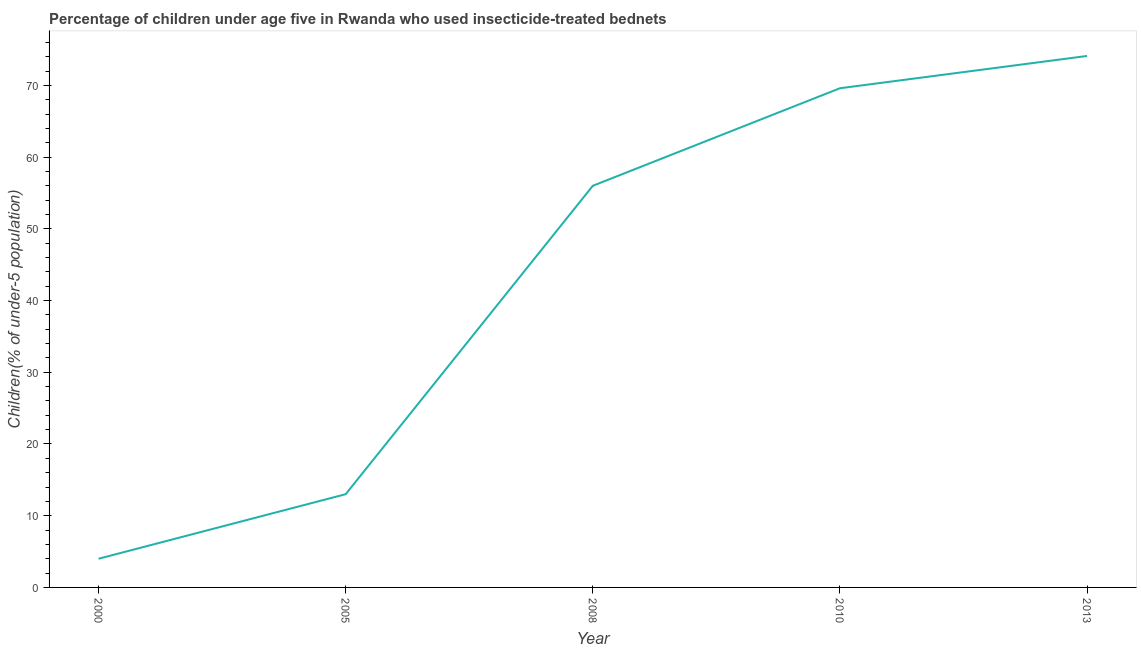What is the percentage of children who use of insecticide-treated bed nets in 2013?
Your response must be concise. 74.1. Across all years, what is the maximum percentage of children who use of insecticide-treated bed nets?
Your answer should be very brief. 74.1. What is the sum of the percentage of children who use of insecticide-treated bed nets?
Provide a succinct answer. 216.7. What is the difference between the percentage of children who use of insecticide-treated bed nets in 2008 and 2013?
Make the answer very short. -18.1. What is the average percentage of children who use of insecticide-treated bed nets per year?
Provide a short and direct response. 43.34. What is the median percentage of children who use of insecticide-treated bed nets?
Your answer should be compact. 56. In how many years, is the percentage of children who use of insecticide-treated bed nets greater than 66 %?
Offer a terse response. 2. What is the ratio of the percentage of children who use of insecticide-treated bed nets in 2005 to that in 2010?
Offer a terse response. 0.19. What is the difference between the highest and the lowest percentage of children who use of insecticide-treated bed nets?
Your answer should be compact. 70.1. Does the percentage of children who use of insecticide-treated bed nets monotonically increase over the years?
Provide a short and direct response. Yes. How many lines are there?
Give a very brief answer. 1. Are the values on the major ticks of Y-axis written in scientific E-notation?
Your response must be concise. No. Does the graph contain any zero values?
Offer a very short reply. No. Does the graph contain grids?
Keep it short and to the point. No. What is the title of the graph?
Your answer should be very brief. Percentage of children under age five in Rwanda who used insecticide-treated bednets. What is the label or title of the Y-axis?
Keep it short and to the point. Children(% of under-5 population). What is the Children(% of under-5 population) in 2010?
Your answer should be very brief. 69.6. What is the Children(% of under-5 population) of 2013?
Ensure brevity in your answer.  74.1. What is the difference between the Children(% of under-5 population) in 2000 and 2005?
Provide a succinct answer. -9. What is the difference between the Children(% of under-5 population) in 2000 and 2008?
Provide a short and direct response. -52. What is the difference between the Children(% of under-5 population) in 2000 and 2010?
Make the answer very short. -65.6. What is the difference between the Children(% of under-5 population) in 2000 and 2013?
Provide a succinct answer. -70.1. What is the difference between the Children(% of under-5 population) in 2005 and 2008?
Keep it short and to the point. -43. What is the difference between the Children(% of under-5 population) in 2005 and 2010?
Make the answer very short. -56.6. What is the difference between the Children(% of under-5 population) in 2005 and 2013?
Your answer should be compact. -61.1. What is the difference between the Children(% of under-5 population) in 2008 and 2010?
Offer a very short reply. -13.6. What is the difference between the Children(% of under-5 population) in 2008 and 2013?
Your answer should be very brief. -18.1. What is the ratio of the Children(% of under-5 population) in 2000 to that in 2005?
Your answer should be very brief. 0.31. What is the ratio of the Children(% of under-5 population) in 2000 to that in 2008?
Provide a succinct answer. 0.07. What is the ratio of the Children(% of under-5 population) in 2000 to that in 2010?
Offer a very short reply. 0.06. What is the ratio of the Children(% of under-5 population) in 2000 to that in 2013?
Your response must be concise. 0.05. What is the ratio of the Children(% of under-5 population) in 2005 to that in 2008?
Offer a very short reply. 0.23. What is the ratio of the Children(% of under-5 population) in 2005 to that in 2010?
Offer a very short reply. 0.19. What is the ratio of the Children(% of under-5 population) in 2005 to that in 2013?
Provide a short and direct response. 0.17. What is the ratio of the Children(% of under-5 population) in 2008 to that in 2010?
Provide a succinct answer. 0.81. What is the ratio of the Children(% of under-5 population) in 2008 to that in 2013?
Offer a terse response. 0.76. What is the ratio of the Children(% of under-5 population) in 2010 to that in 2013?
Your response must be concise. 0.94. 